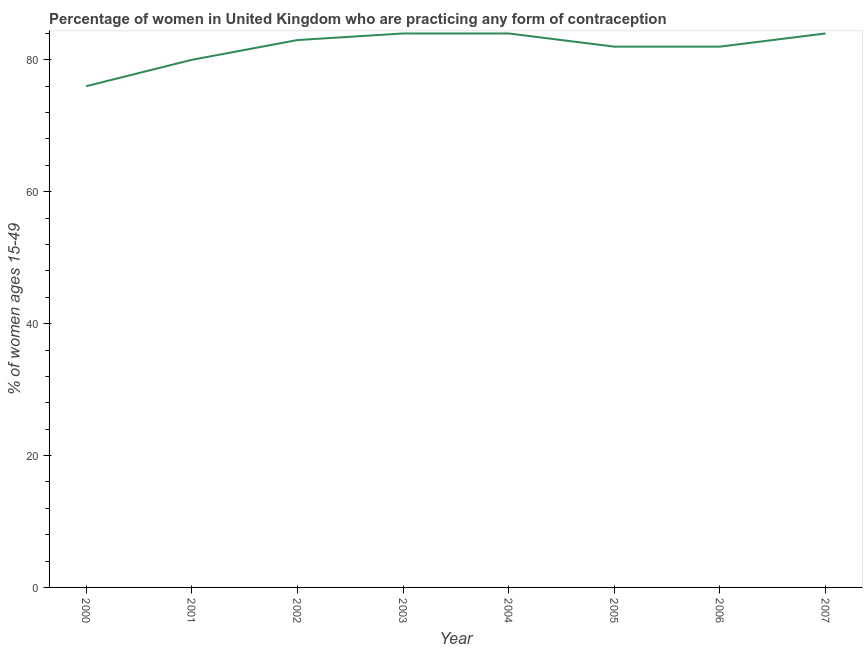What is the contraceptive prevalence in 2005?
Ensure brevity in your answer.  82. Across all years, what is the maximum contraceptive prevalence?
Offer a terse response. 84. Across all years, what is the minimum contraceptive prevalence?
Make the answer very short. 76. In which year was the contraceptive prevalence maximum?
Your answer should be compact. 2003. What is the sum of the contraceptive prevalence?
Offer a terse response. 655. What is the difference between the contraceptive prevalence in 2003 and 2004?
Provide a short and direct response. 0. What is the average contraceptive prevalence per year?
Make the answer very short. 81.88. What is the median contraceptive prevalence?
Keep it short and to the point. 82.5. In how many years, is the contraceptive prevalence greater than 68 %?
Make the answer very short. 8. Do a majority of the years between 2000 and 2002 (inclusive) have contraceptive prevalence greater than 60 %?
Provide a succinct answer. Yes. What is the ratio of the contraceptive prevalence in 2002 to that in 2005?
Ensure brevity in your answer.  1.01. Is the contraceptive prevalence in 2004 less than that in 2006?
Your response must be concise. No. Is the sum of the contraceptive prevalence in 2002 and 2003 greater than the maximum contraceptive prevalence across all years?
Your response must be concise. Yes. What is the difference between the highest and the lowest contraceptive prevalence?
Your answer should be compact. 8. In how many years, is the contraceptive prevalence greater than the average contraceptive prevalence taken over all years?
Ensure brevity in your answer.  6. Does the contraceptive prevalence monotonically increase over the years?
Your answer should be compact. No. How many lines are there?
Give a very brief answer. 1. What is the difference between two consecutive major ticks on the Y-axis?
Provide a short and direct response. 20. Are the values on the major ticks of Y-axis written in scientific E-notation?
Provide a succinct answer. No. What is the title of the graph?
Provide a succinct answer. Percentage of women in United Kingdom who are practicing any form of contraception. What is the label or title of the X-axis?
Keep it short and to the point. Year. What is the label or title of the Y-axis?
Your response must be concise. % of women ages 15-49. What is the % of women ages 15-49 of 2000?
Provide a short and direct response. 76. What is the % of women ages 15-49 in 2001?
Your answer should be compact. 80. What is the % of women ages 15-49 of 2003?
Your answer should be very brief. 84. What is the % of women ages 15-49 of 2007?
Offer a terse response. 84. What is the difference between the % of women ages 15-49 in 2000 and 2003?
Offer a very short reply. -8. What is the difference between the % of women ages 15-49 in 2000 and 2005?
Make the answer very short. -6. What is the difference between the % of women ages 15-49 in 2001 and 2002?
Provide a succinct answer. -3. What is the difference between the % of women ages 15-49 in 2001 and 2003?
Ensure brevity in your answer.  -4. What is the difference between the % of women ages 15-49 in 2001 and 2004?
Your answer should be very brief. -4. What is the difference between the % of women ages 15-49 in 2001 and 2007?
Offer a terse response. -4. What is the difference between the % of women ages 15-49 in 2002 and 2003?
Your answer should be very brief. -1. What is the difference between the % of women ages 15-49 in 2003 and 2004?
Provide a succinct answer. 0. What is the difference between the % of women ages 15-49 in 2004 and 2006?
Your answer should be compact. 2. What is the difference between the % of women ages 15-49 in 2005 and 2006?
Your answer should be very brief. 0. What is the difference between the % of women ages 15-49 in 2005 and 2007?
Offer a terse response. -2. What is the ratio of the % of women ages 15-49 in 2000 to that in 2002?
Offer a very short reply. 0.92. What is the ratio of the % of women ages 15-49 in 2000 to that in 2003?
Your answer should be very brief. 0.91. What is the ratio of the % of women ages 15-49 in 2000 to that in 2004?
Provide a succinct answer. 0.91. What is the ratio of the % of women ages 15-49 in 2000 to that in 2005?
Make the answer very short. 0.93. What is the ratio of the % of women ages 15-49 in 2000 to that in 2006?
Your answer should be very brief. 0.93. What is the ratio of the % of women ages 15-49 in 2000 to that in 2007?
Offer a terse response. 0.91. What is the ratio of the % of women ages 15-49 in 2001 to that in 2002?
Give a very brief answer. 0.96. What is the ratio of the % of women ages 15-49 in 2001 to that in 2003?
Give a very brief answer. 0.95. What is the ratio of the % of women ages 15-49 in 2001 to that in 2004?
Ensure brevity in your answer.  0.95. What is the ratio of the % of women ages 15-49 in 2001 to that in 2005?
Provide a succinct answer. 0.98. What is the ratio of the % of women ages 15-49 in 2001 to that in 2006?
Make the answer very short. 0.98. What is the ratio of the % of women ages 15-49 in 2001 to that in 2007?
Make the answer very short. 0.95. What is the ratio of the % of women ages 15-49 in 2002 to that in 2003?
Give a very brief answer. 0.99. What is the ratio of the % of women ages 15-49 in 2002 to that in 2005?
Provide a short and direct response. 1.01. What is the ratio of the % of women ages 15-49 in 2003 to that in 2005?
Offer a terse response. 1.02. What is the ratio of the % of women ages 15-49 in 2003 to that in 2007?
Your answer should be very brief. 1. What is the ratio of the % of women ages 15-49 in 2004 to that in 2005?
Your answer should be compact. 1.02. What is the ratio of the % of women ages 15-49 in 2004 to that in 2007?
Your response must be concise. 1. What is the ratio of the % of women ages 15-49 in 2005 to that in 2006?
Provide a succinct answer. 1. 